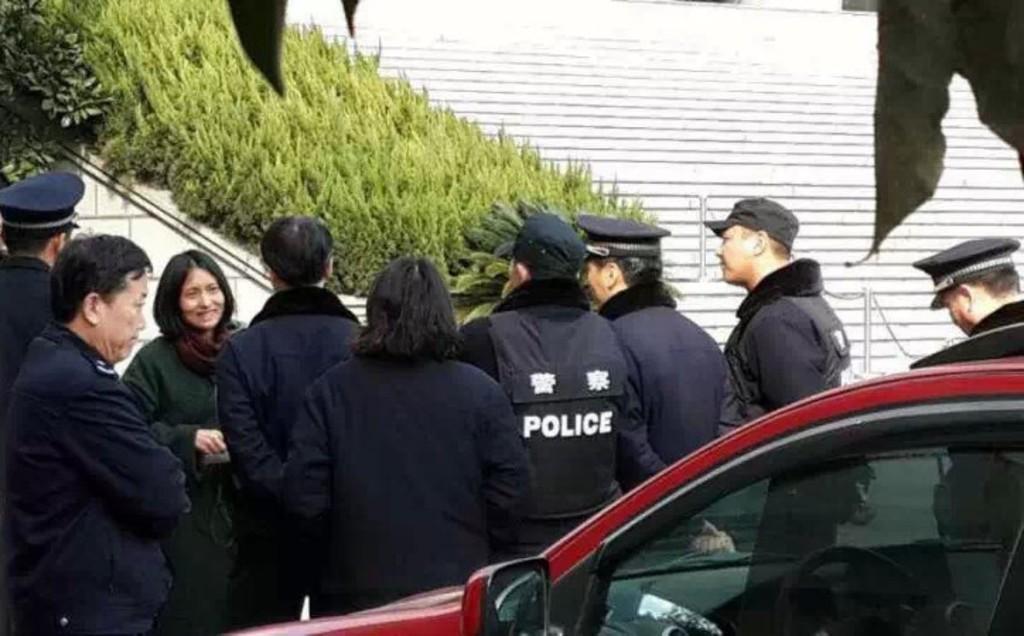How would you summarize this image in a sentence or two? This picture describes about group of people, they are all standing, beside to them we can see a car, in the background we can find grass and metal rods. 